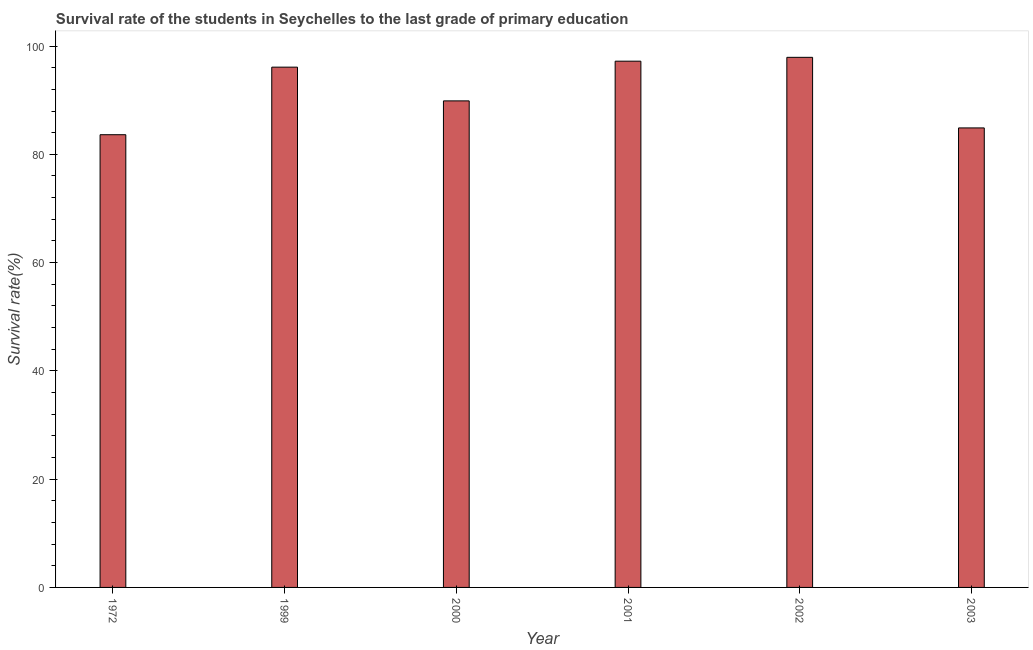Does the graph contain any zero values?
Ensure brevity in your answer.  No. What is the title of the graph?
Offer a very short reply. Survival rate of the students in Seychelles to the last grade of primary education. What is the label or title of the X-axis?
Your answer should be compact. Year. What is the label or title of the Y-axis?
Offer a terse response. Survival rate(%). What is the survival rate in primary education in 1999?
Keep it short and to the point. 96.1. Across all years, what is the maximum survival rate in primary education?
Your answer should be compact. 97.92. Across all years, what is the minimum survival rate in primary education?
Offer a very short reply. 83.62. In which year was the survival rate in primary education maximum?
Your response must be concise. 2002. What is the sum of the survival rate in primary education?
Provide a succinct answer. 549.61. What is the difference between the survival rate in primary education in 1972 and 1999?
Offer a terse response. -12.48. What is the average survival rate in primary education per year?
Keep it short and to the point. 91.6. What is the median survival rate in primary education?
Give a very brief answer. 92.99. Do a majority of the years between 2003 and 1972 (inclusive) have survival rate in primary education greater than 8 %?
Your answer should be very brief. Yes. What is the ratio of the survival rate in primary education in 2001 to that in 2002?
Provide a succinct answer. 0.99. What is the difference between the highest and the second highest survival rate in primary education?
Your answer should be compact. 0.71. What is the difference between the highest and the lowest survival rate in primary education?
Your answer should be compact. 14.29. In how many years, is the survival rate in primary education greater than the average survival rate in primary education taken over all years?
Provide a succinct answer. 3. How many bars are there?
Give a very brief answer. 6. How many years are there in the graph?
Your answer should be very brief. 6. Are the values on the major ticks of Y-axis written in scientific E-notation?
Make the answer very short. No. What is the Survival rate(%) in 1972?
Your response must be concise. 83.62. What is the Survival rate(%) of 1999?
Your response must be concise. 96.1. What is the Survival rate(%) in 2000?
Provide a short and direct response. 89.87. What is the Survival rate(%) of 2001?
Make the answer very short. 97.21. What is the Survival rate(%) of 2002?
Provide a succinct answer. 97.92. What is the Survival rate(%) in 2003?
Make the answer very short. 84.88. What is the difference between the Survival rate(%) in 1972 and 1999?
Offer a terse response. -12.48. What is the difference between the Survival rate(%) in 1972 and 2000?
Keep it short and to the point. -6.25. What is the difference between the Survival rate(%) in 1972 and 2001?
Keep it short and to the point. -13.58. What is the difference between the Survival rate(%) in 1972 and 2002?
Give a very brief answer. -14.29. What is the difference between the Survival rate(%) in 1972 and 2003?
Your answer should be very brief. -1.25. What is the difference between the Survival rate(%) in 1999 and 2000?
Provide a succinct answer. 6.23. What is the difference between the Survival rate(%) in 1999 and 2001?
Make the answer very short. -1.1. What is the difference between the Survival rate(%) in 1999 and 2002?
Offer a terse response. -1.81. What is the difference between the Survival rate(%) in 1999 and 2003?
Provide a short and direct response. 11.23. What is the difference between the Survival rate(%) in 2000 and 2001?
Provide a succinct answer. -7.33. What is the difference between the Survival rate(%) in 2000 and 2002?
Provide a short and direct response. -8.04. What is the difference between the Survival rate(%) in 2000 and 2003?
Offer a terse response. 4.99. What is the difference between the Survival rate(%) in 2001 and 2002?
Your answer should be very brief. -0.71. What is the difference between the Survival rate(%) in 2001 and 2003?
Give a very brief answer. 12.33. What is the difference between the Survival rate(%) in 2002 and 2003?
Your answer should be very brief. 13.04. What is the ratio of the Survival rate(%) in 1972 to that in 1999?
Ensure brevity in your answer.  0.87. What is the ratio of the Survival rate(%) in 1972 to that in 2001?
Ensure brevity in your answer.  0.86. What is the ratio of the Survival rate(%) in 1972 to that in 2002?
Provide a succinct answer. 0.85. What is the ratio of the Survival rate(%) in 1972 to that in 2003?
Offer a very short reply. 0.98. What is the ratio of the Survival rate(%) in 1999 to that in 2000?
Make the answer very short. 1.07. What is the ratio of the Survival rate(%) in 1999 to that in 2001?
Your answer should be compact. 0.99. What is the ratio of the Survival rate(%) in 1999 to that in 2002?
Ensure brevity in your answer.  0.98. What is the ratio of the Survival rate(%) in 1999 to that in 2003?
Your response must be concise. 1.13. What is the ratio of the Survival rate(%) in 2000 to that in 2001?
Your answer should be very brief. 0.93. What is the ratio of the Survival rate(%) in 2000 to that in 2002?
Offer a very short reply. 0.92. What is the ratio of the Survival rate(%) in 2000 to that in 2003?
Your answer should be very brief. 1.06. What is the ratio of the Survival rate(%) in 2001 to that in 2002?
Your answer should be very brief. 0.99. What is the ratio of the Survival rate(%) in 2001 to that in 2003?
Offer a terse response. 1.15. What is the ratio of the Survival rate(%) in 2002 to that in 2003?
Your response must be concise. 1.15. 